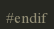Convert code to text. <code><loc_0><loc_0><loc_500><loc_500><_C_>
#endif

</code> 